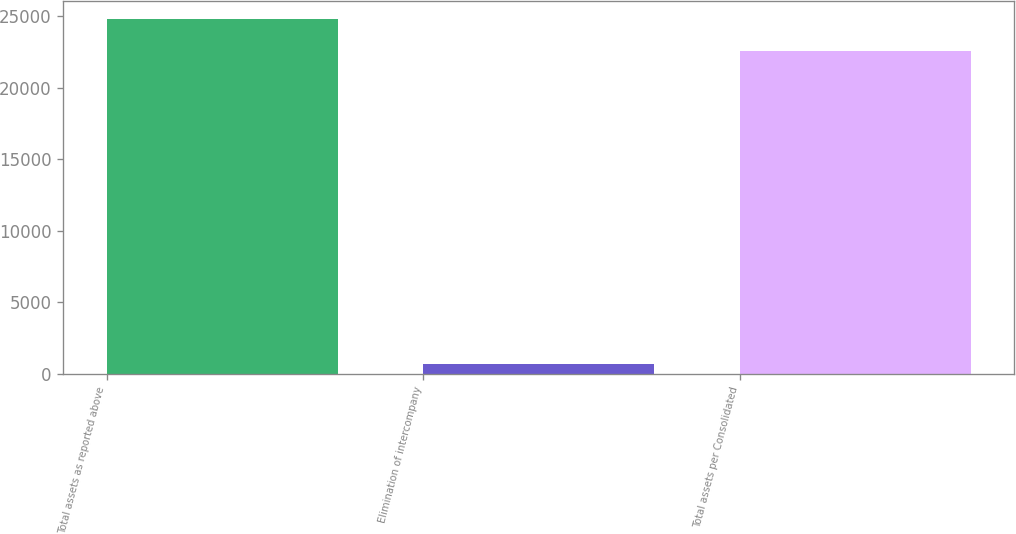Convert chart to OTSL. <chart><loc_0><loc_0><loc_500><loc_500><bar_chart><fcel>Total assets as reported above<fcel>Elimination of intercompany<fcel>Total assets per Consolidated<nl><fcel>24825.9<fcel>672<fcel>22569<nl></chart> 